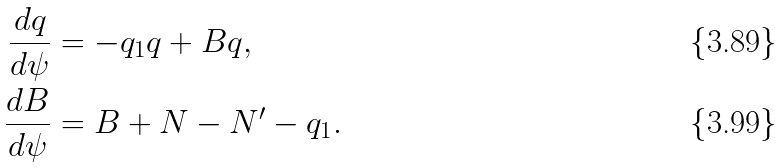Convert formula to latex. <formula><loc_0><loc_0><loc_500><loc_500>\frac { d q } { d \psi } & = - q _ { 1 } q + B q , \\ \frac { d B } { d \psi } & = B + N - N ^ { \prime } - q _ { 1 } .</formula> 